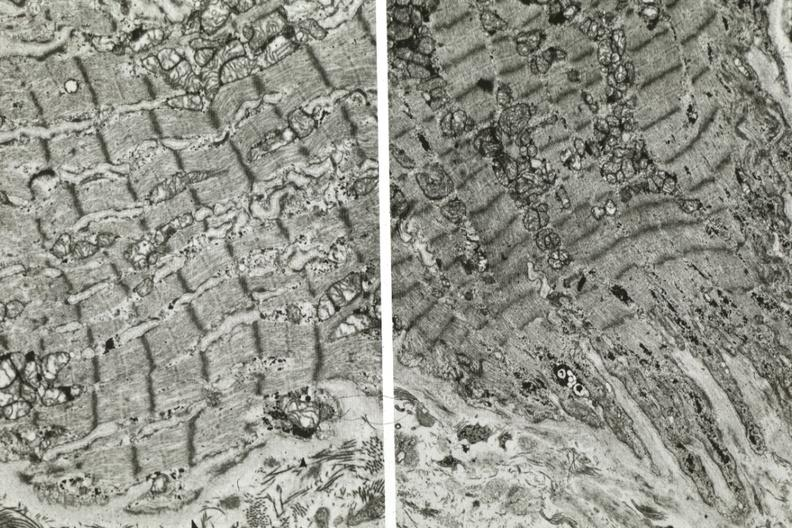s cardiovascular present?
Answer the question using a single word or phrase. Yes 